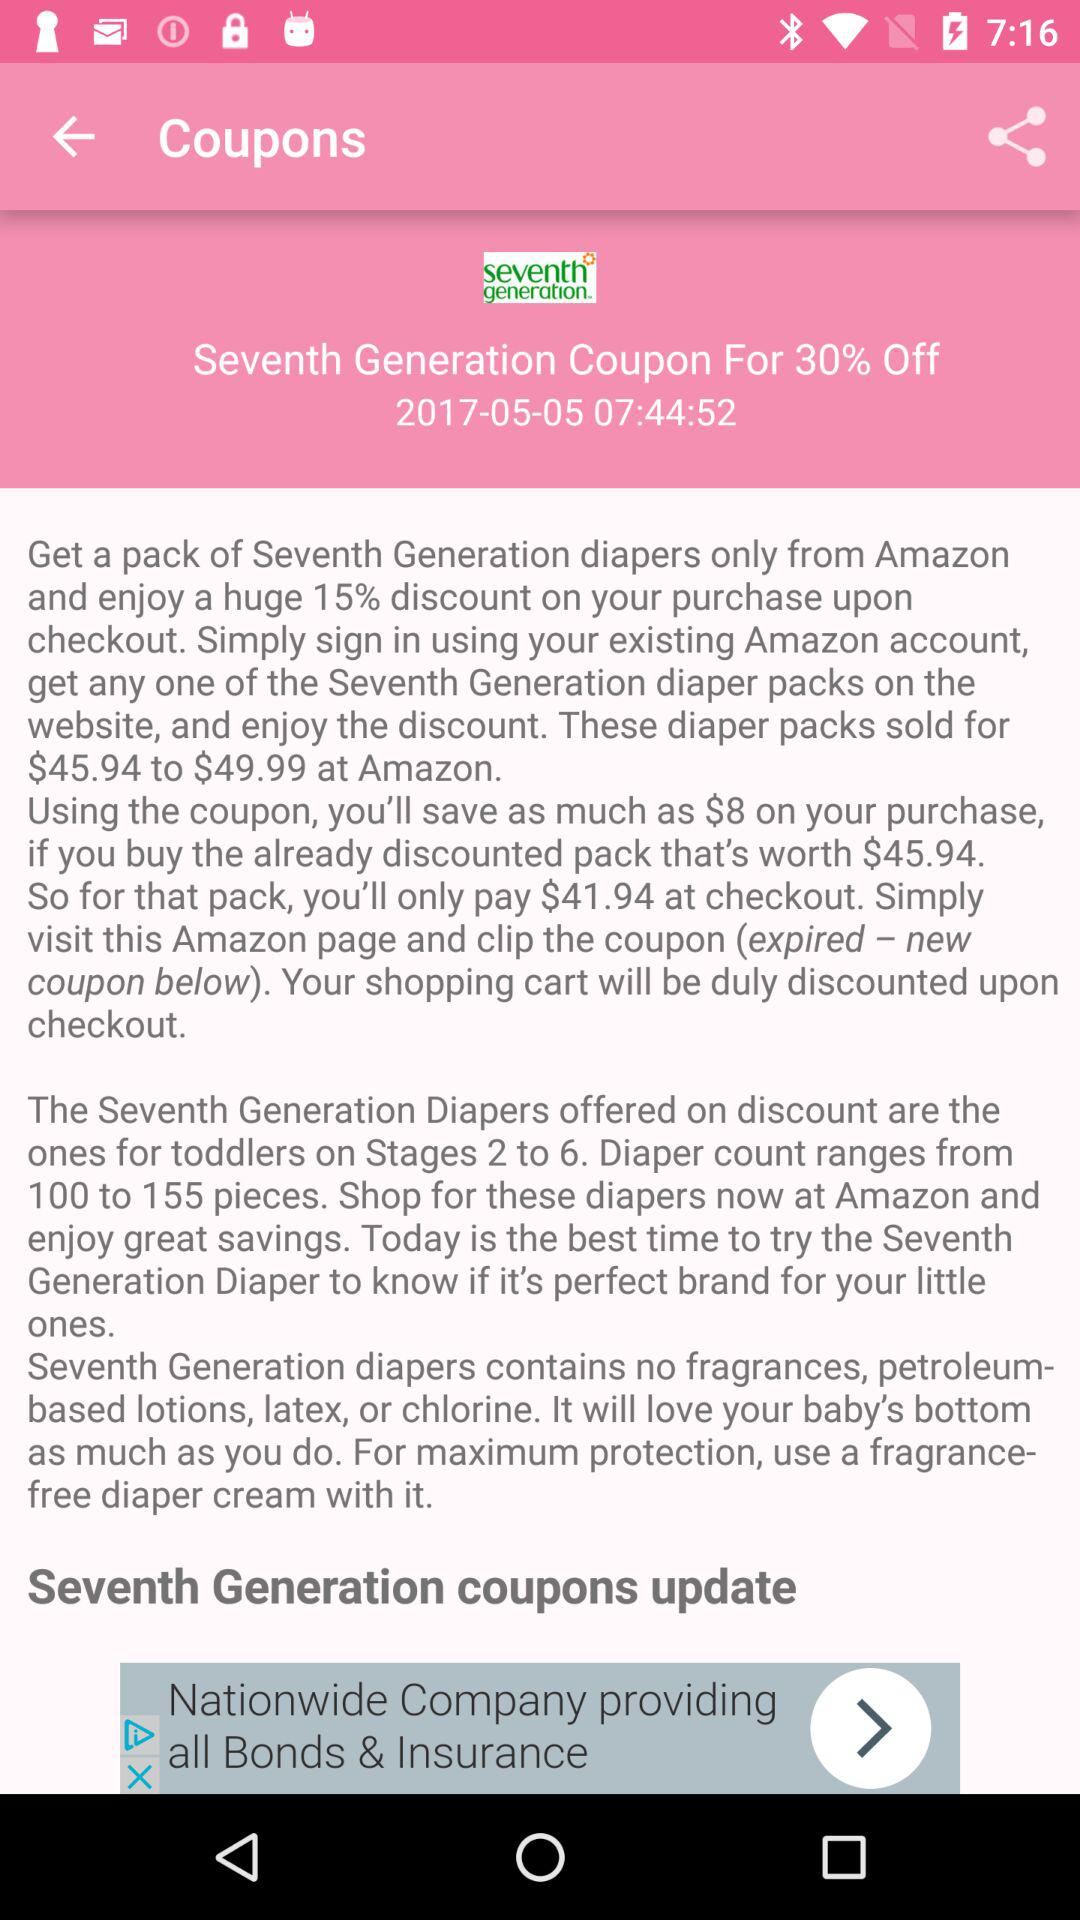What's the percentage off on the "Seventh Generation" coupon? The percentage off is 30. 